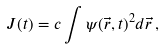Convert formula to latex. <formula><loc_0><loc_0><loc_500><loc_500>J ( t ) = c \int \psi ( \vec { r } , t ) ^ { 2 } d \vec { r } \, ,</formula> 